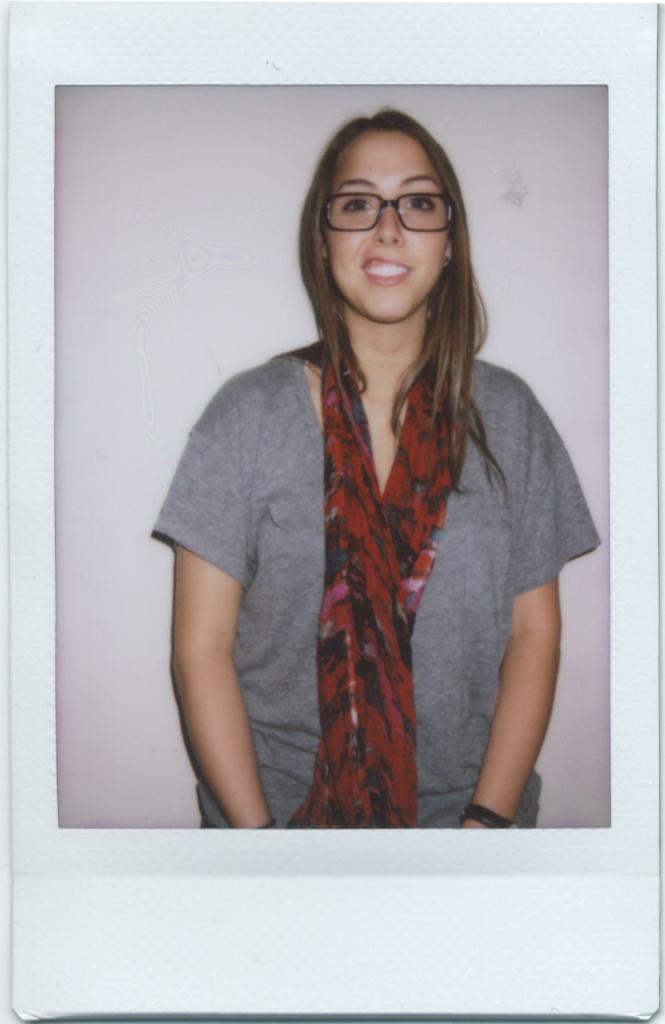Who is the main subject in the image? There is a woman in the image. What is the woman wearing on her upper body? The woman is wearing a gray T-shirt. What accessory is the woman wearing around her neck? The woman is wearing a scarf in red color. What can be seen in the background of the image? There is a wall in the background of the image. How many rabbits are playing with kittens in the image? There are no rabbits or kittens present in the image; it features a woman wearing a gray T-shirt and a red scarf. Is the woman in the image being held in a prison? There is no indication of a prison or any confinement in the image; it shows a woman standing in front of a wall. 